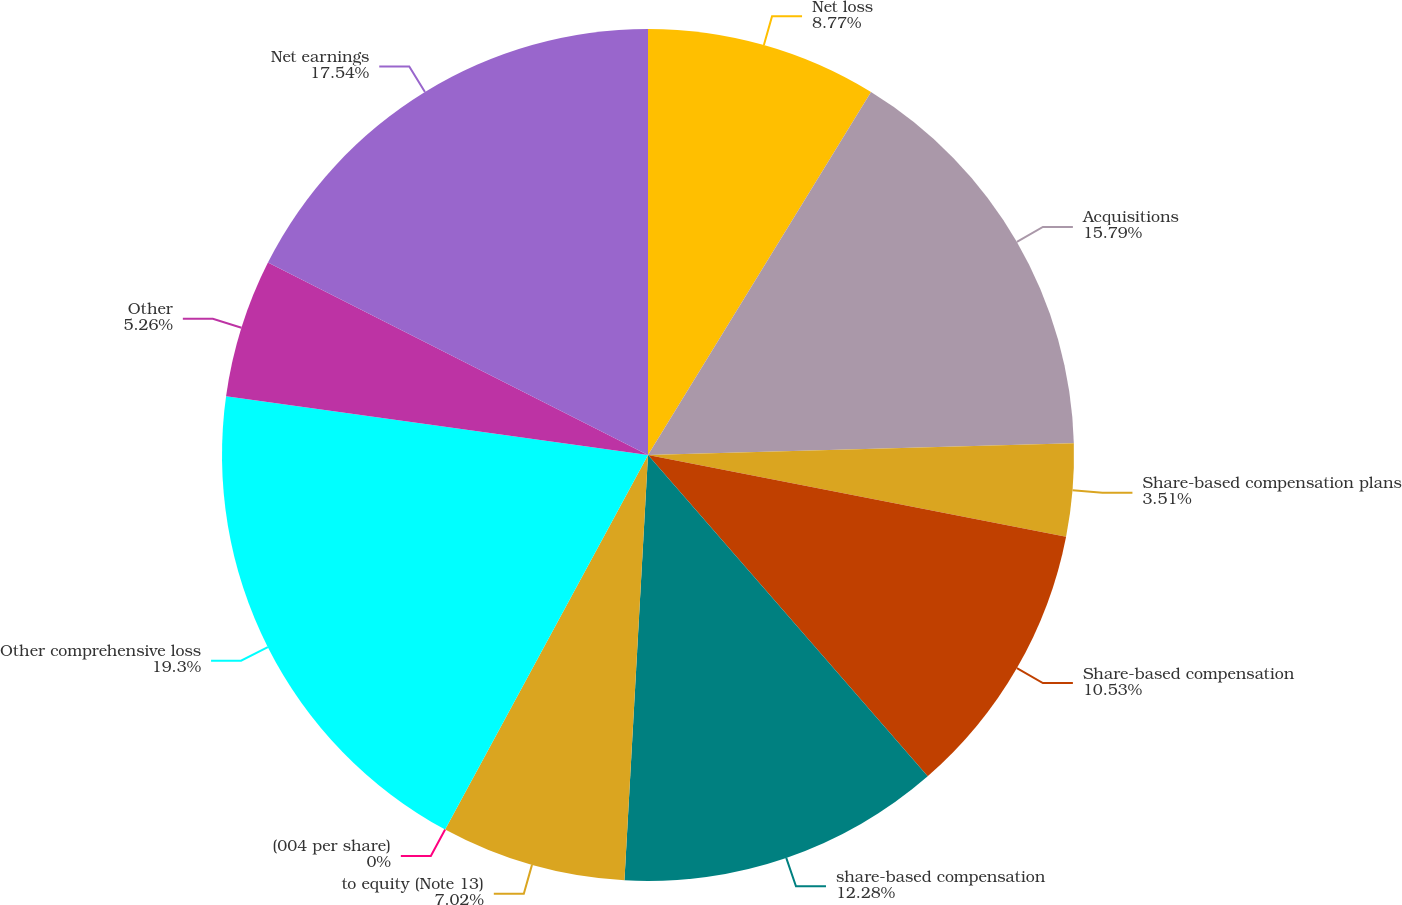<chart> <loc_0><loc_0><loc_500><loc_500><pie_chart><fcel>Net loss<fcel>Acquisitions<fcel>Share-based compensation plans<fcel>Share-based compensation<fcel>share-based compensation<fcel>to equity (Note 13)<fcel>(004 per share)<fcel>Other comprehensive loss<fcel>Other<fcel>Net earnings<nl><fcel>8.77%<fcel>15.79%<fcel>3.51%<fcel>10.53%<fcel>12.28%<fcel>7.02%<fcel>0.0%<fcel>19.3%<fcel>5.26%<fcel>17.54%<nl></chart> 